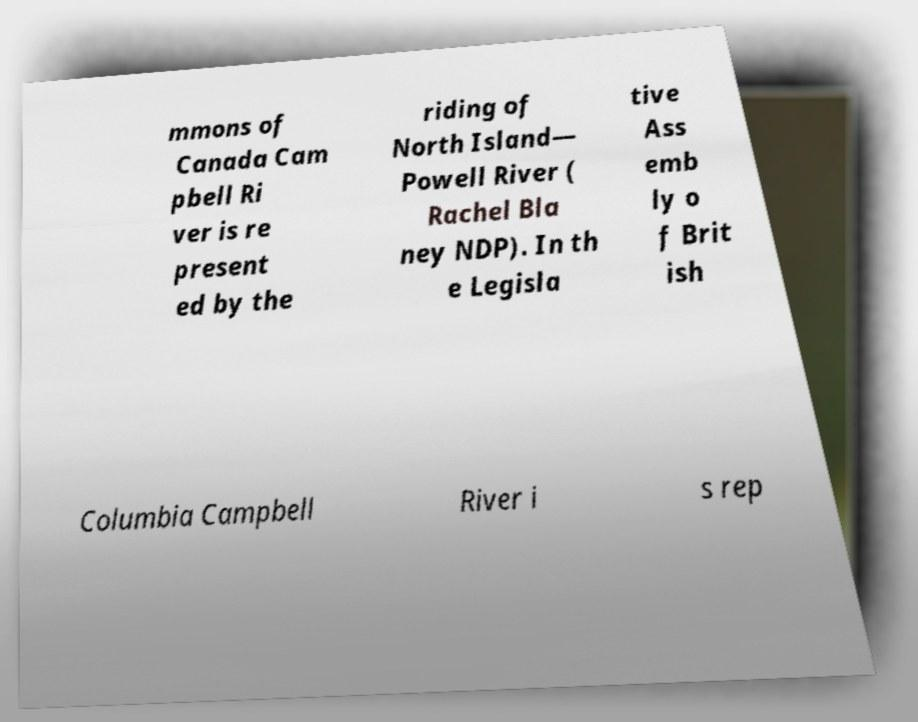Please read and relay the text visible in this image. What does it say? mmons of Canada Cam pbell Ri ver is re present ed by the riding of North Island— Powell River ( Rachel Bla ney NDP). In th e Legisla tive Ass emb ly o f Brit ish Columbia Campbell River i s rep 